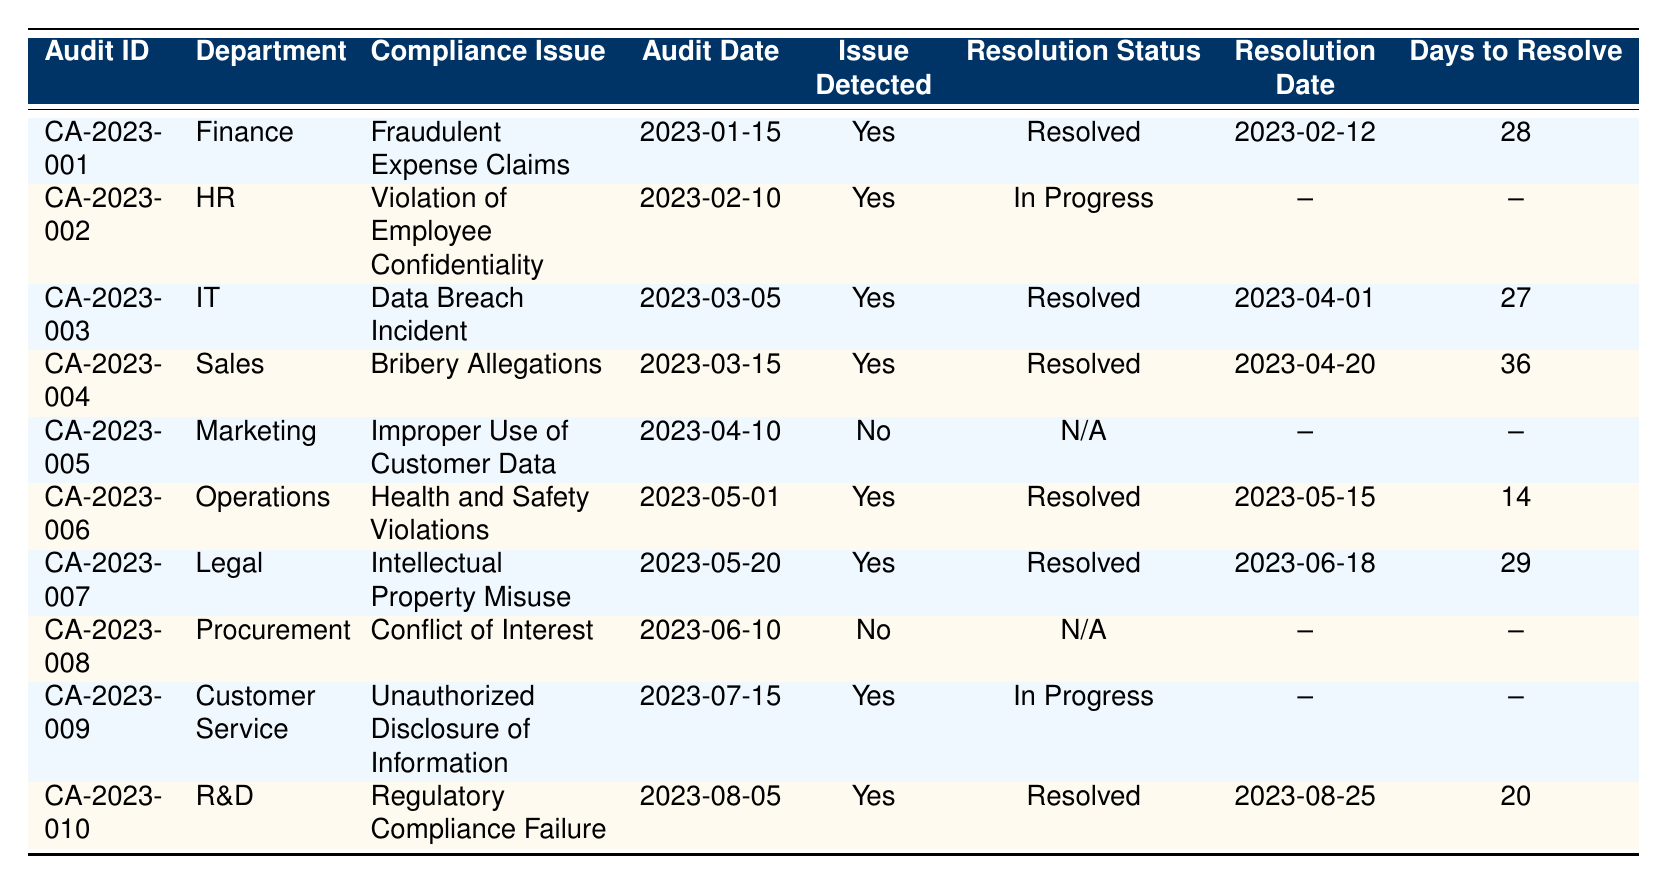What is the compliance issue reported in the IT department? In the table, the IT department's compliance issue is listed under the "Compliance Issue" column for the row where the "Department" is IT. This row indicates the compliance issue is "Data Breach Incident."
Answer: Data Breach Incident How many days did it take to resolve the issue in the Finance department? Looking at the row for the Finance department, under "Days to Resolve," the value is 28 days, which indicates the time taken to resolve the identified compliance issue.
Answer: 28 days Was there a compliance issue identified in the Marketing department? In the table for the Marketing department, the "Issue Detected" column shows "No," indicating that there was no compliance issue identified during the audit for that department.
Answer: No Which department had the longest resolution time, and how long did it take? By examining all the "Days to Resolve" values, the Sales department's time of 36 days is the highest. Therefore, it had the longest resolution time.
Answer: Sales department, 36 days How many departments have unresolved compliance issues? The table shows two departments—HR and Customer Service—where the resolution status is "In Progress." Therefore, there are two departments with unresolved compliance issues.
Answer: 2 departments What is the average resolution time for the departments where issues were resolved? The resolved cases are Finance (28), IT (27), Sales (36), Operations (14), Legal (29), and R&D (20). Summing these values gives 28 + 27 + 36 + 14 + 29 + 20 = 154. There are six resolved cases, so the average is 154/6 = 25.67 days.
Answer: 25.67 days Which department had a compliance issue involving employee confidentiality, and what is its resolution status? The HR department is noted for the compliance issue "Violation of Employee Confidentiality," and according to the "Resolution Status" column, it is currently marked as "In Progress."
Answer: HR department, In Progress Is there any department where the compliance issue was detected but has not yet been resolved? The table indicates the HR department and the Customer Service department both have detected compliance issues but have not resolved them, as their "Resolution Status" is "In Progress."
Answer: Yes What is the total number of compliance audits performed across all departments? Counting the rows in the table, there is a total of 10 audits listed, with one row for each audit indicating compliance checks have been performed.
Answer: 10 audits How many compliance issues were resolved within 20 days? From the "Days to Resolve" column, only the Operations (14 days) and R&D (20 days) departments had compliance issues resolved within 20 days. Therefore, there are two compliance issues resolved within this timeframe.
Answer: 2 issues 